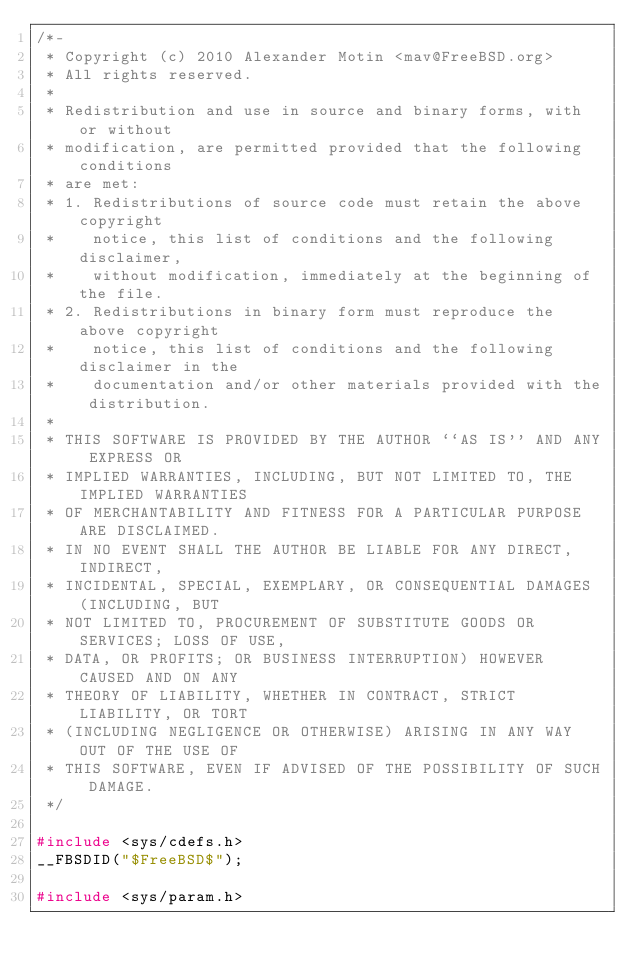Convert code to text. <code><loc_0><loc_0><loc_500><loc_500><_C_>/*-
 * Copyright (c) 2010 Alexander Motin <mav@FreeBSD.org>
 * All rights reserved.
 *
 * Redistribution and use in source and binary forms, with or without
 * modification, are permitted provided that the following conditions
 * are met:
 * 1. Redistributions of source code must retain the above copyright
 *    notice, this list of conditions and the following disclaimer,
 *    without modification, immediately at the beginning of the file.
 * 2. Redistributions in binary form must reproduce the above copyright
 *    notice, this list of conditions and the following disclaimer in the
 *    documentation and/or other materials provided with the distribution.
 *
 * THIS SOFTWARE IS PROVIDED BY THE AUTHOR ``AS IS'' AND ANY EXPRESS OR
 * IMPLIED WARRANTIES, INCLUDING, BUT NOT LIMITED TO, THE IMPLIED WARRANTIES
 * OF MERCHANTABILITY AND FITNESS FOR A PARTICULAR PURPOSE ARE DISCLAIMED.
 * IN NO EVENT SHALL THE AUTHOR BE LIABLE FOR ANY DIRECT, INDIRECT,
 * INCIDENTAL, SPECIAL, EXEMPLARY, OR CONSEQUENTIAL DAMAGES (INCLUDING, BUT
 * NOT LIMITED TO, PROCUREMENT OF SUBSTITUTE GOODS OR SERVICES; LOSS OF USE,
 * DATA, OR PROFITS; OR BUSINESS INTERRUPTION) HOWEVER CAUSED AND ON ANY
 * THEORY OF LIABILITY, WHETHER IN CONTRACT, STRICT LIABILITY, OR TORT
 * (INCLUDING NEGLIGENCE OR OTHERWISE) ARISING IN ANY WAY OUT OF THE USE OF
 * THIS SOFTWARE, EVEN IF ADVISED OF THE POSSIBILITY OF SUCH DAMAGE.
 */

#include <sys/cdefs.h>
__FBSDID("$FreeBSD$");

#include <sys/param.h></code> 